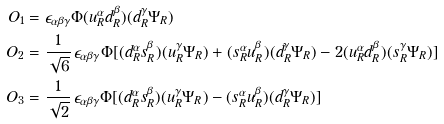Convert formula to latex. <formula><loc_0><loc_0><loc_500><loc_500>O _ { 1 } & = \epsilon _ { \alpha \beta \gamma } \Phi ( u ^ { \alpha } _ { R } d _ { R } ^ { \beta } ) ( d _ { R } ^ { \gamma } \Psi _ { R } ) \\ O _ { 2 } & = \frac { 1 } { \sqrt { 6 } } \, \epsilon _ { \alpha \beta \gamma } \Phi [ ( d ^ { \alpha } _ { R } s _ { R } ^ { \beta } ) ( u _ { R } ^ { \gamma } \Psi _ { R } ) + ( s ^ { \alpha } _ { R } u _ { R } ^ { \beta } ) ( d _ { R } ^ { \gamma } \Psi _ { R } ) - 2 ( u ^ { \alpha } _ { R } d _ { R } ^ { \beta } ) ( s _ { R } ^ { \gamma } \Psi _ { R } ) ] \\ O _ { 3 } & = \frac { 1 } { \sqrt { 2 } } \, \epsilon _ { \alpha \beta \gamma } \Phi [ ( d ^ { \alpha } _ { R } s _ { R } ^ { \beta } ) ( u _ { R } ^ { \gamma } \Psi _ { R } ) - ( s ^ { \alpha } _ { R } u _ { R } ^ { \beta } ) ( d _ { R } ^ { \gamma } \Psi _ { R } ) ]</formula> 